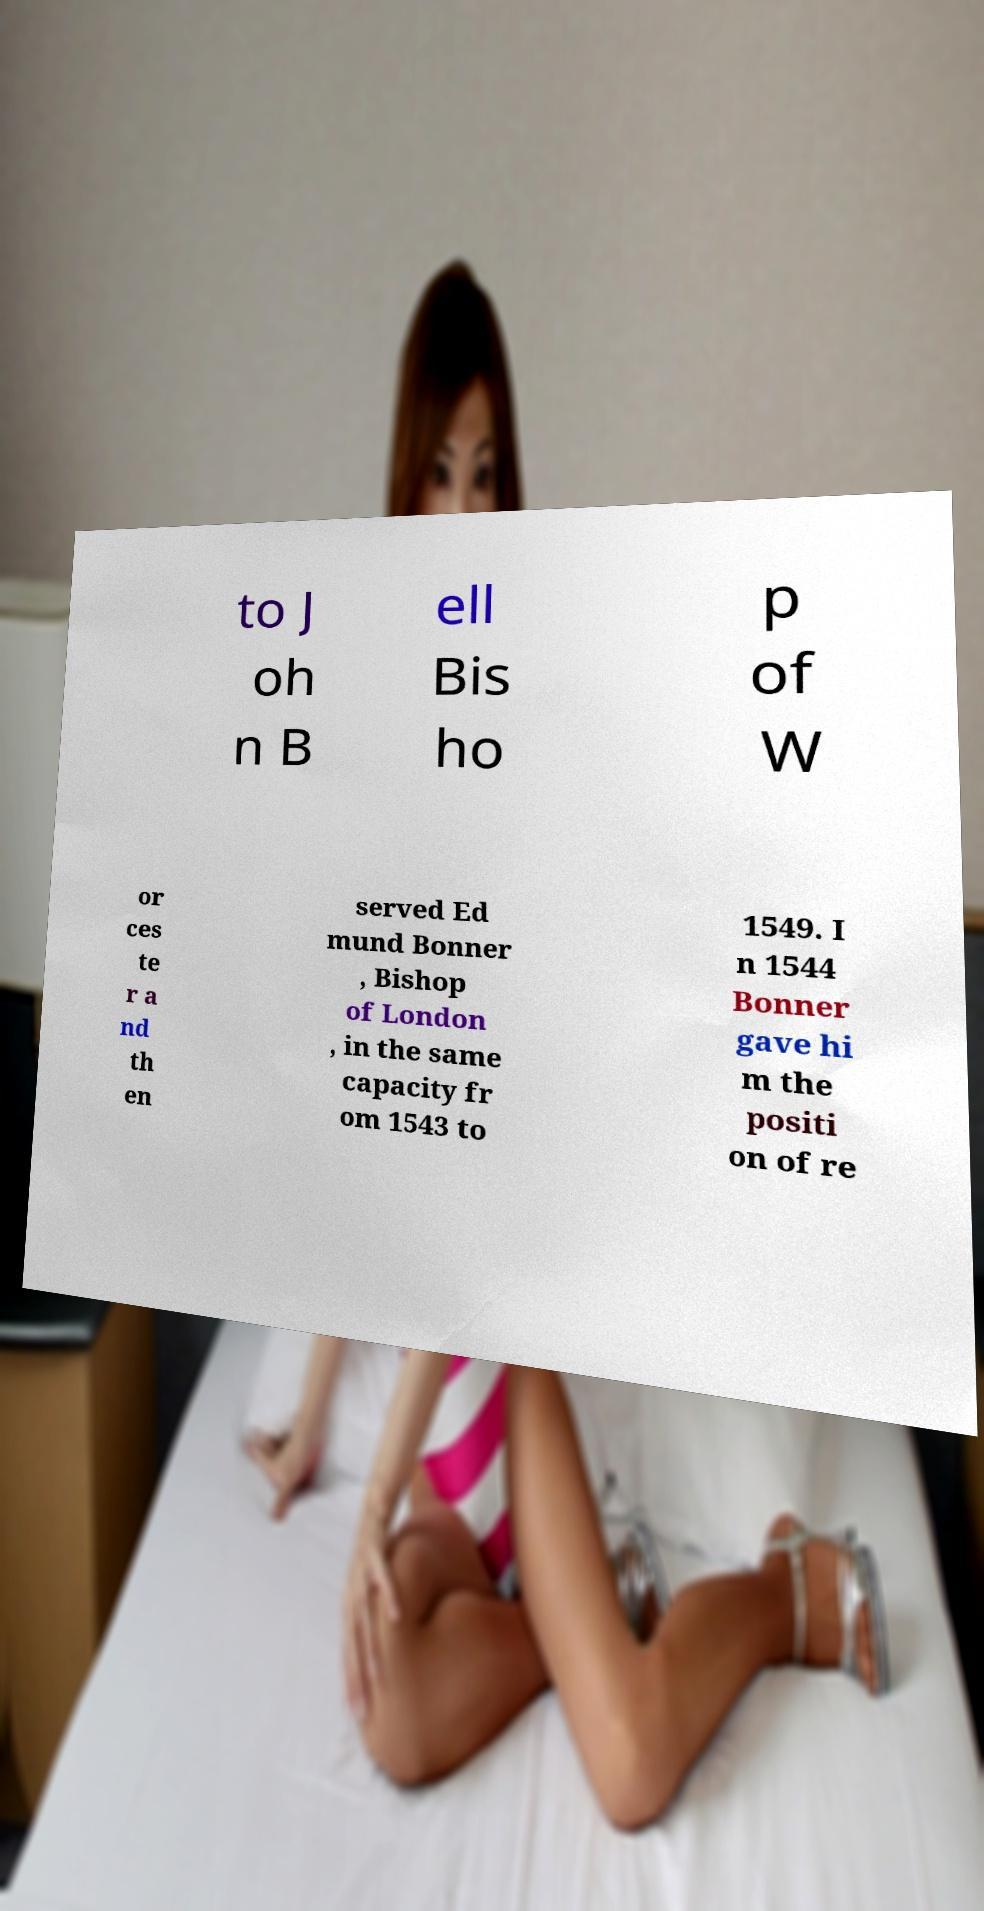Could you assist in decoding the text presented in this image and type it out clearly? to J oh n B ell Bis ho p of W or ces te r a nd th en served Ed mund Bonner , Bishop of London , in the same capacity fr om 1543 to 1549. I n 1544 Bonner gave hi m the positi on of re 